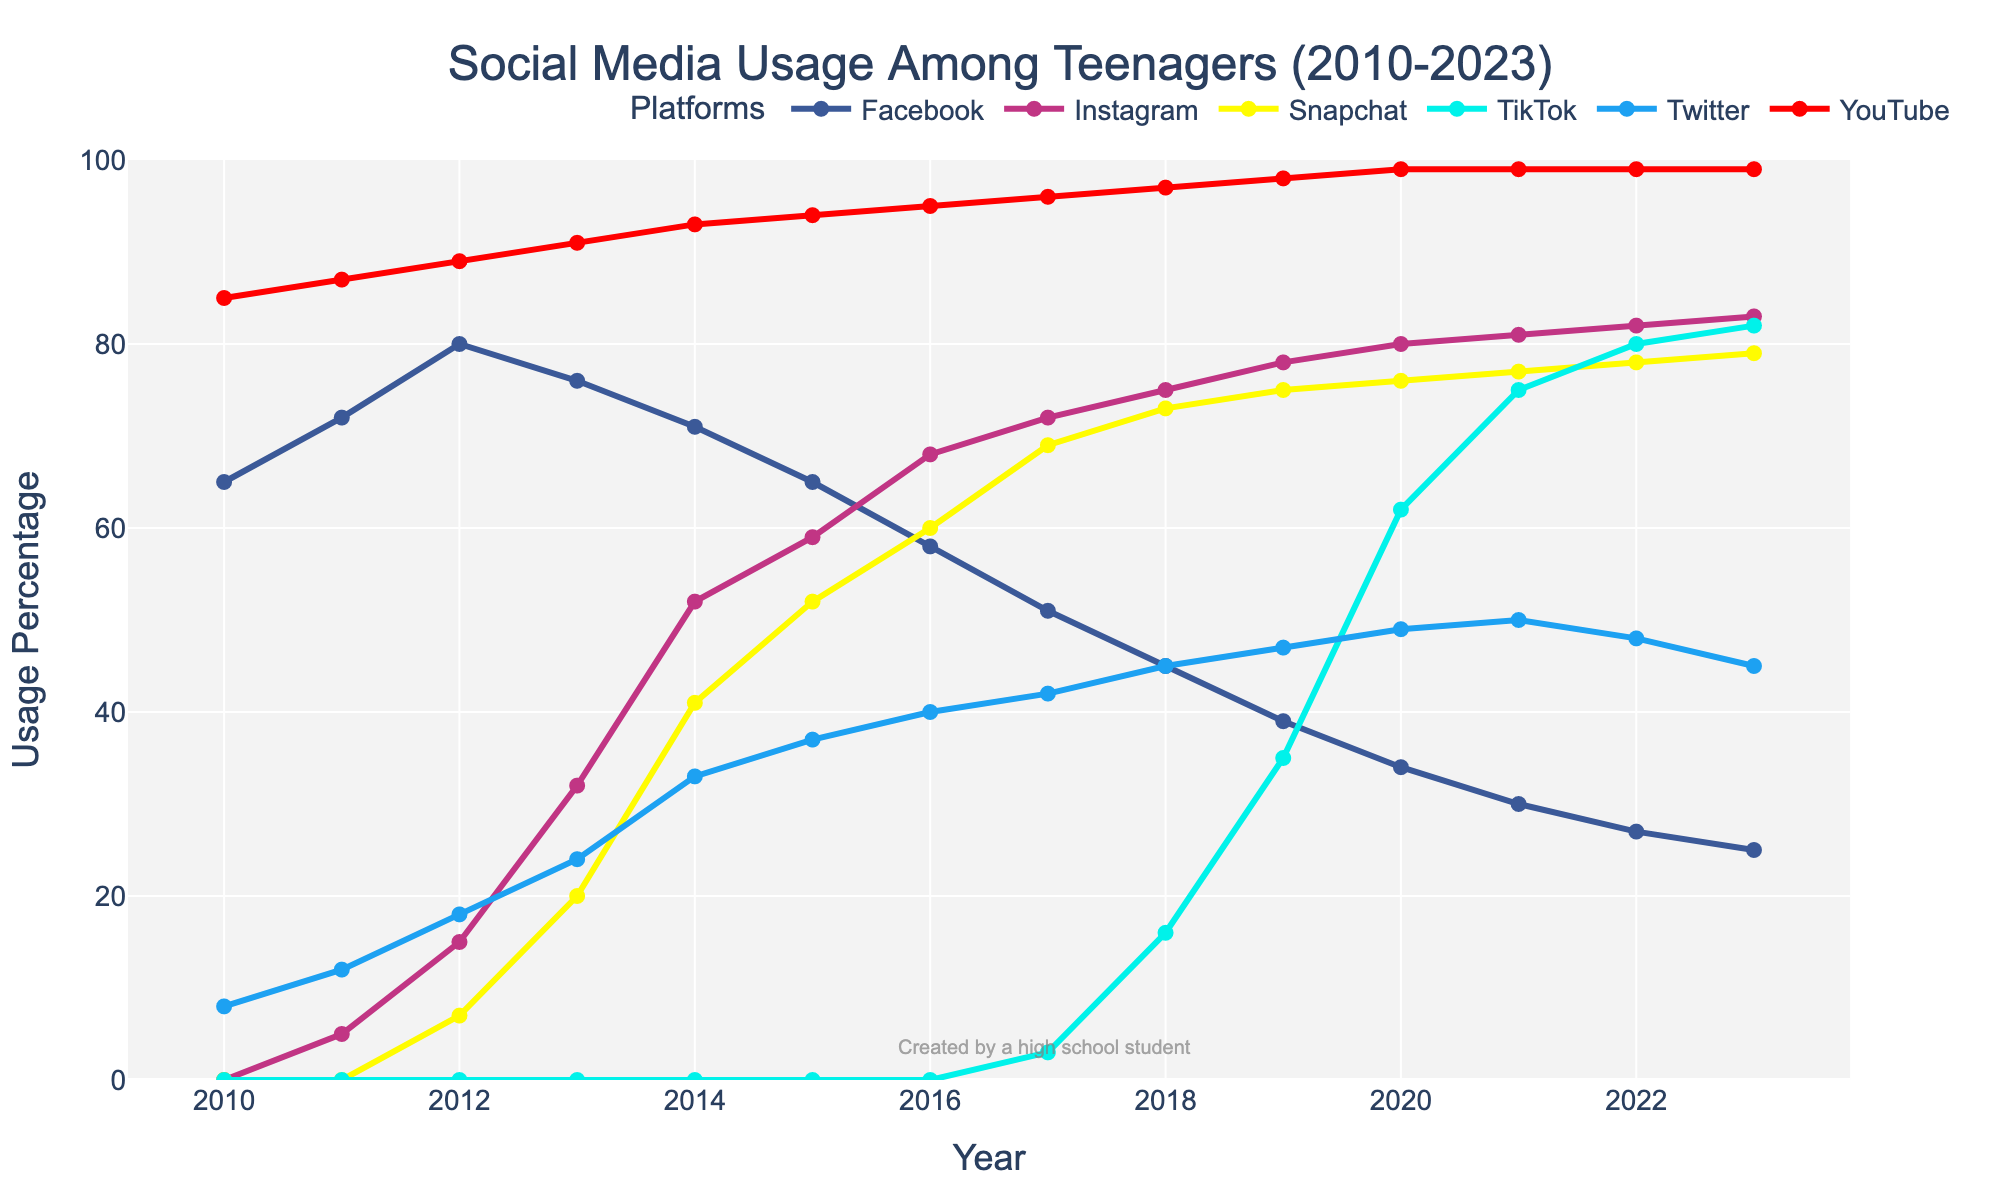How has Facebook usage among teenagers changed from 2010 to 2023? To answer this question, observe the trend line representing Facebook. It starts at 65% in 2010 and gradually decreases to 25% by 2023.
Answer: Decreased from 65% to 25% Which year did Instagram usage surpass Facebook usage among teenagers? Look for the point where the Instagram line crosses above the Facebook line. This occurs between 2013 and 2014, so in 2014, Instagram usage surpasses Facebook usage.
Answer: 2014 What is the overall trend in YouTube usage among teenagers from 2010 to 2023? Analyze the YouTube line on the chart. It starts at 85% in 2010 and steadily increases to 99% by 2019, remaining stable thereafter.
Answer: Increasing trend In what year did TikTok usage among teenagers significantly start to rise? Identify the year when the TikTok line starts to rise steeply. This happens around 2019 where it jumps from 3% in 2017 to 16% in 2018 and then to 35% in 2019.
Answer: 2019 What is the difference in Snapchat usage between the years 2014 and 2019? Find the Snapchat values for 2014 and 2019 on the chart. Snapchat usage was 41% in 2014 and 75% in 2019. The difference is 75% - 41%.
Answer: 34% Which platform saw the most steady increase in usage from 2010 to 2023? Examine the trend of each platform. YouTube shows a very consistent increase without major dips, starting from 85% to 99%.
Answer: YouTube In 2023, which platform has the highest usage among teenagers? Look at the 2023 endpoints of the lines. The highest line belongs to YouTube at 99%.
Answer: YouTube Compare the usage of Twitter and TikTok among teenagers in 2021. Which one has higher usage and by how much? Identify the values for Twitter and TikTok in 2021. Twitter is at 50%, and TikTok is at 75%. The difference is 75% - 50%.
Answer: TikTok by 25% Which platform saw the sharpest decrease in usage from its peak to 2023? Determine the peak usage for each platform and compare it to its 2023 usage. Facebook peaks at 80% in 2012 and drops to 25% in 2023, a decrease of 55 percentage points.
Answer: Facebook How does average Instagram usage from 2015 to 2020 compare to average Snapchat usage over the same period? Sum the Instagram values from 2015-2020 and divide by 6: (59+68+72+75+78+80)/6 = 72%. For Snapchat: Sum the values from 2015-2020 (52+60+69+73+75+76)/6 = 67.5%.
Answer: Instagram: 72%, Snapchat: 67.5% 